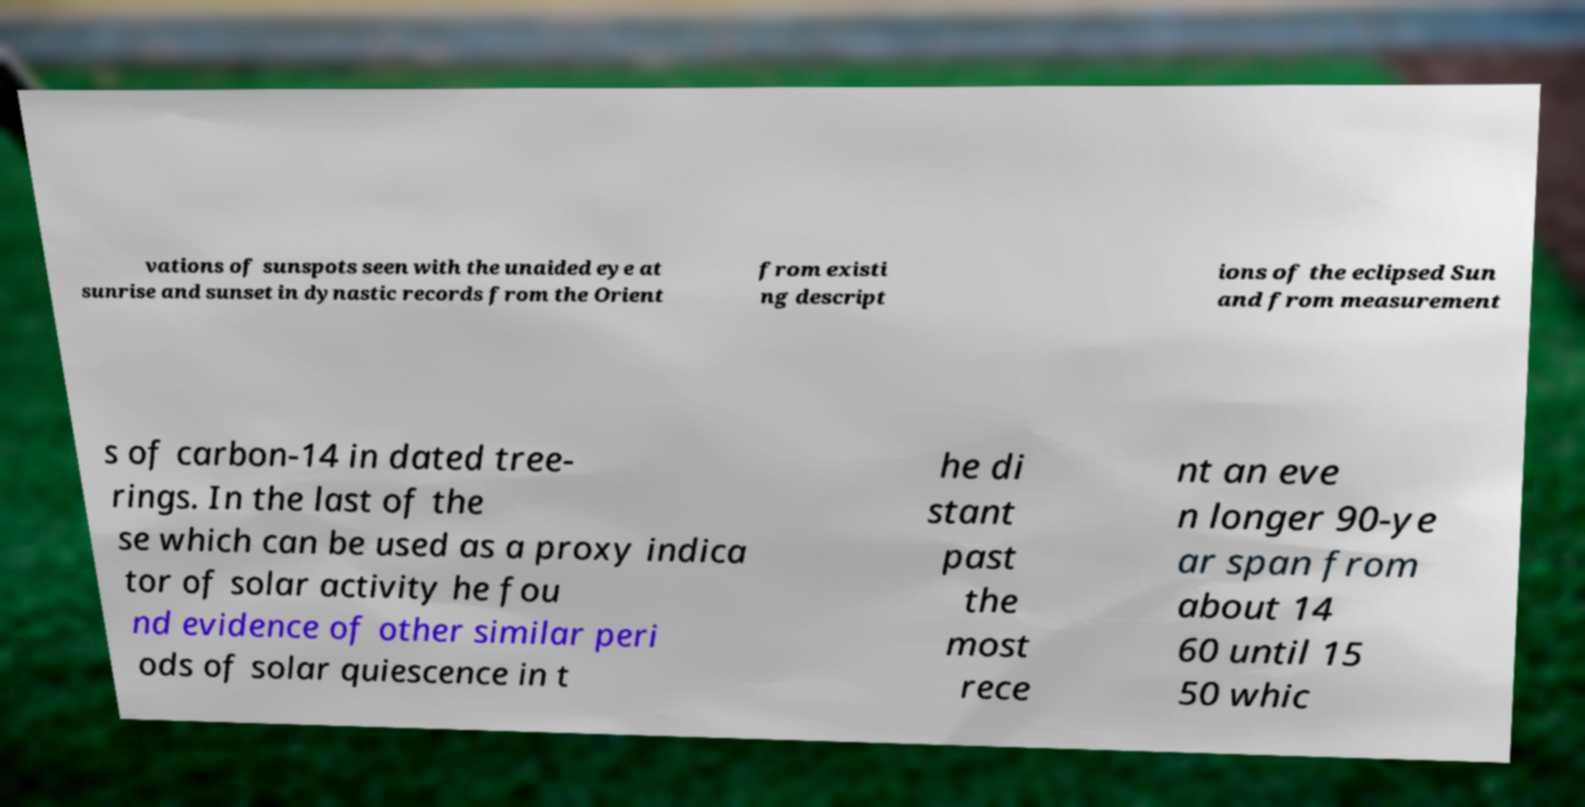Can you accurately transcribe the text from the provided image for me? vations of sunspots seen with the unaided eye at sunrise and sunset in dynastic records from the Orient from existi ng descript ions of the eclipsed Sun and from measurement s of carbon-14 in dated tree- rings. In the last of the se which can be used as a proxy indica tor of solar activity he fou nd evidence of other similar peri ods of solar quiescence in t he di stant past the most rece nt an eve n longer 90-ye ar span from about 14 60 until 15 50 whic 